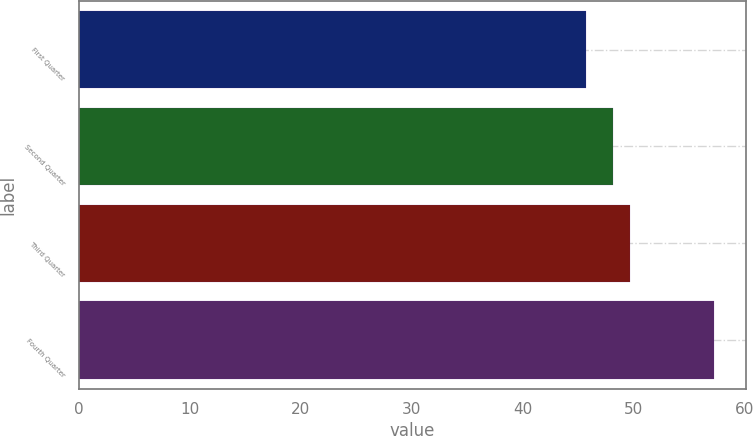Convert chart to OTSL. <chart><loc_0><loc_0><loc_500><loc_500><bar_chart><fcel>First Quarter<fcel>Second Quarter<fcel>Third Quarter<fcel>Fourth Quarter<nl><fcel>45.67<fcel>48.14<fcel>49.63<fcel>57.21<nl></chart> 